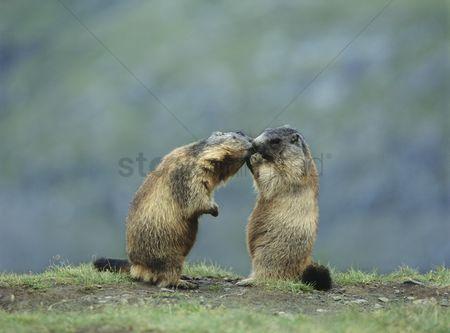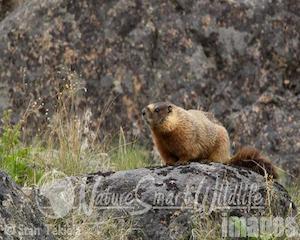The first image is the image on the left, the second image is the image on the right. For the images displayed, is the sentence "There are two rodents in the right image that are facing towards the right." factually correct? Answer yes or no. No. 